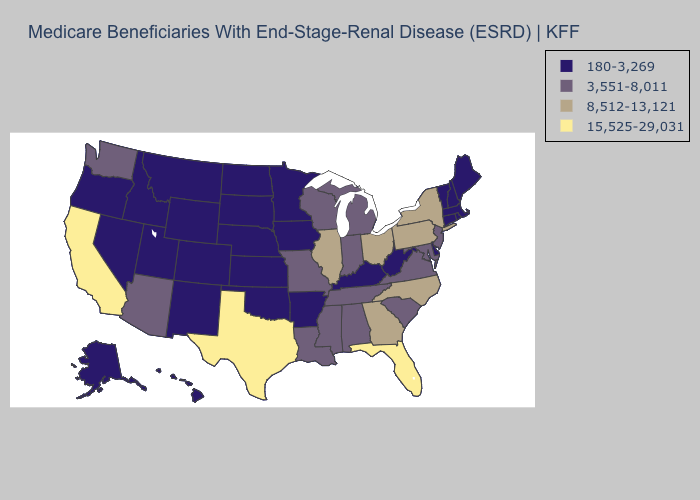What is the highest value in the Northeast ?
Short answer required. 8,512-13,121. Does Rhode Island have the lowest value in the Northeast?
Keep it brief. Yes. How many symbols are there in the legend?
Answer briefly. 4. Name the states that have a value in the range 3,551-8,011?
Concise answer only. Alabama, Arizona, Indiana, Louisiana, Maryland, Michigan, Mississippi, Missouri, New Jersey, South Carolina, Tennessee, Virginia, Washington, Wisconsin. Name the states that have a value in the range 8,512-13,121?
Concise answer only. Georgia, Illinois, New York, North Carolina, Ohio, Pennsylvania. Name the states that have a value in the range 3,551-8,011?
Write a very short answer. Alabama, Arizona, Indiana, Louisiana, Maryland, Michigan, Mississippi, Missouri, New Jersey, South Carolina, Tennessee, Virginia, Washington, Wisconsin. Does Oregon have the same value as Colorado?
Quick response, please. Yes. Among the states that border Arizona , which have the lowest value?
Quick response, please. Colorado, Nevada, New Mexico, Utah. What is the value of Hawaii?
Write a very short answer. 180-3,269. Name the states that have a value in the range 8,512-13,121?
Keep it brief. Georgia, Illinois, New York, North Carolina, Ohio, Pennsylvania. Name the states that have a value in the range 3,551-8,011?
Concise answer only. Alabama, Arizona, Indiana, Louisiana, Maryland, Michigan, Mississippi, Missouri, New Jersey, South Carolina, Tennessee, Virginia, Washington, Wisconsin. Which states have the lowest value in the MidWest?
Concise answer only. Iowa, Kansas, Minnesota, Nebraska, North Dakota, South Dakota. Name the states that have a value in the range 8,512-13,121?
Answer briefly. Georgia, Illinois, New York, North Carolina, Ohio, Pennsylvania. What is the value of Minnesota?
Quick response, please. 180-3,269. 